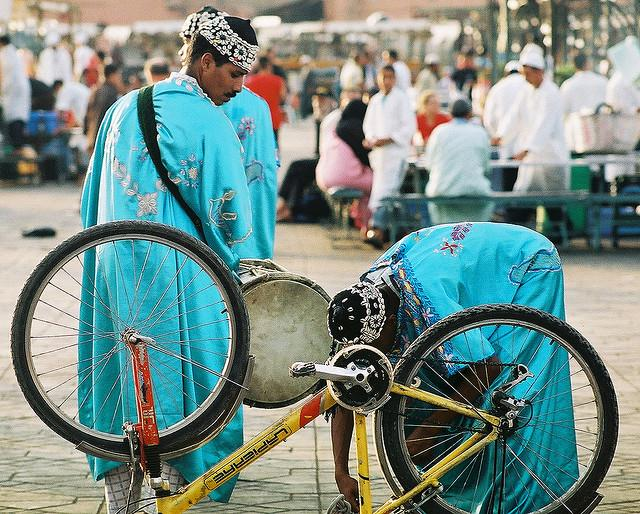What mode of transportation is upside-down? bicycle 